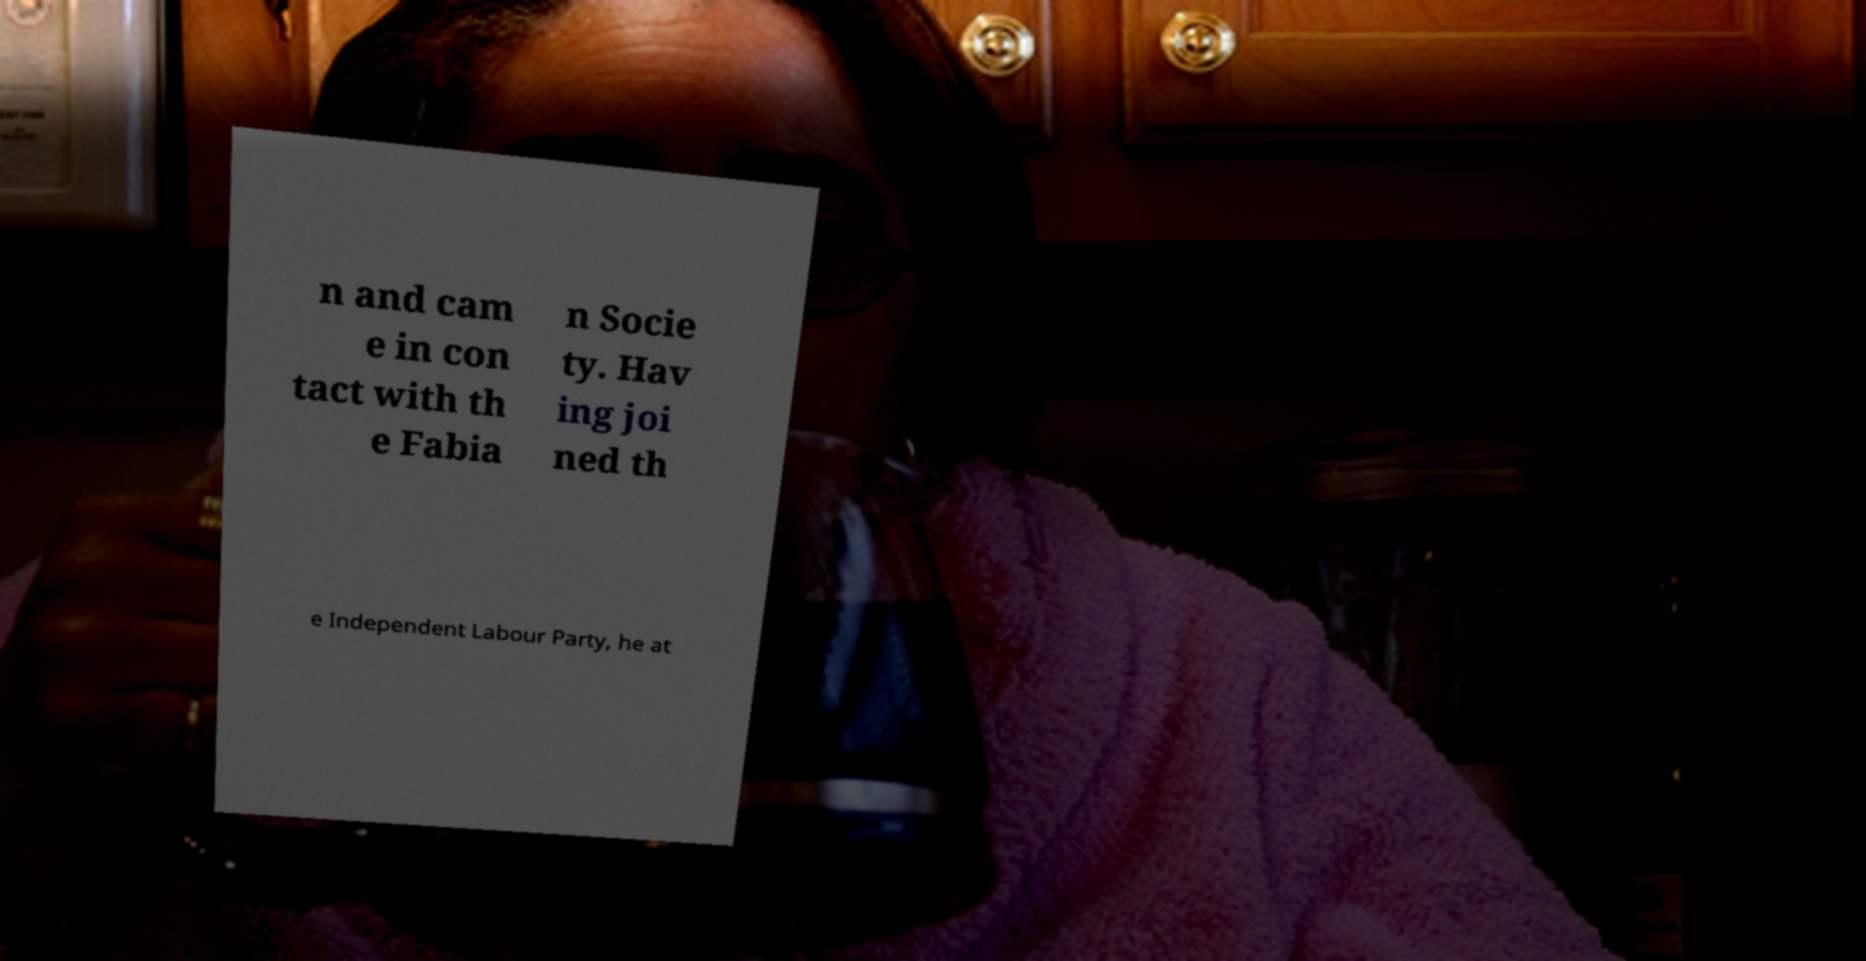What messages or text are displayed in this image? I need them in a readable, typed format. n and cam e in con tact with th e Fabia n Socie ty. Hav ing joi ned th e Independent Labour Party, he at 